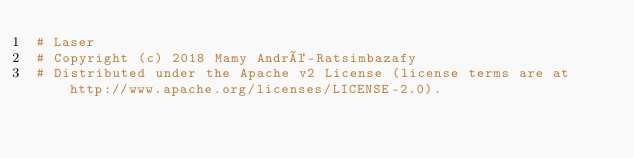Convert code to text. <code><loc_0><loc_0><loc_500><loc_500><_Nim_># Laser
# Copyright (c) 2018 Mamy André-Ratsimbazafy
# Distributed under the Apache v2 License (license terms are at http://www.apache.org/licenses/LICENSE-2.0).</code> 